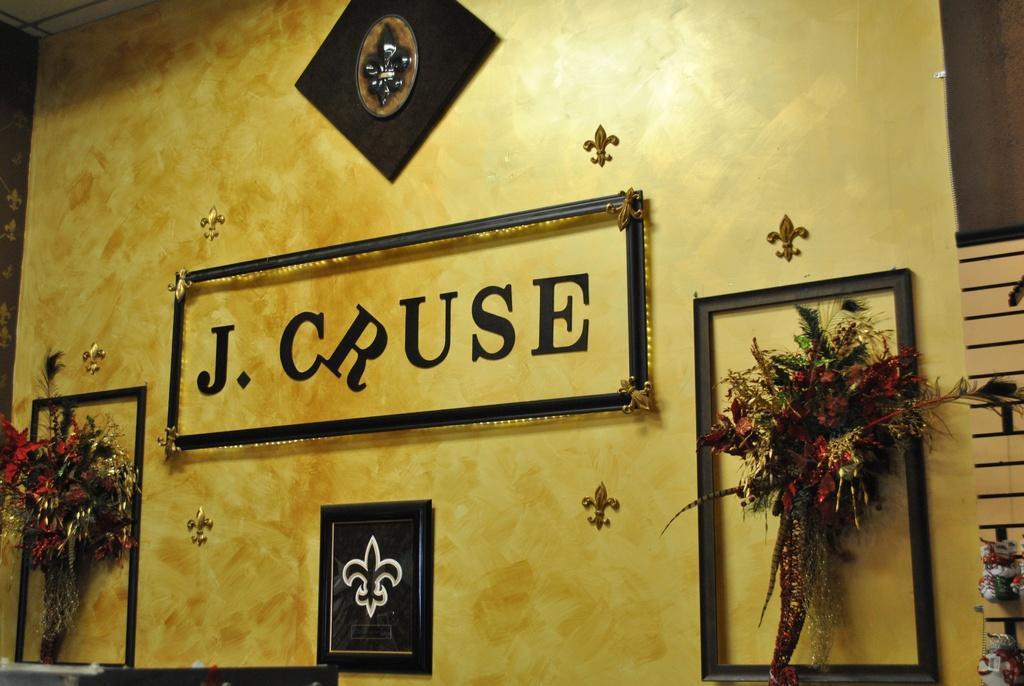In one or two sentences, can you explain what this image depicts? In this image I can see two boutique attache to the wall and the flowers are in red and green color. I can also see a frame attached to the wall and the wall is in yellow color. 